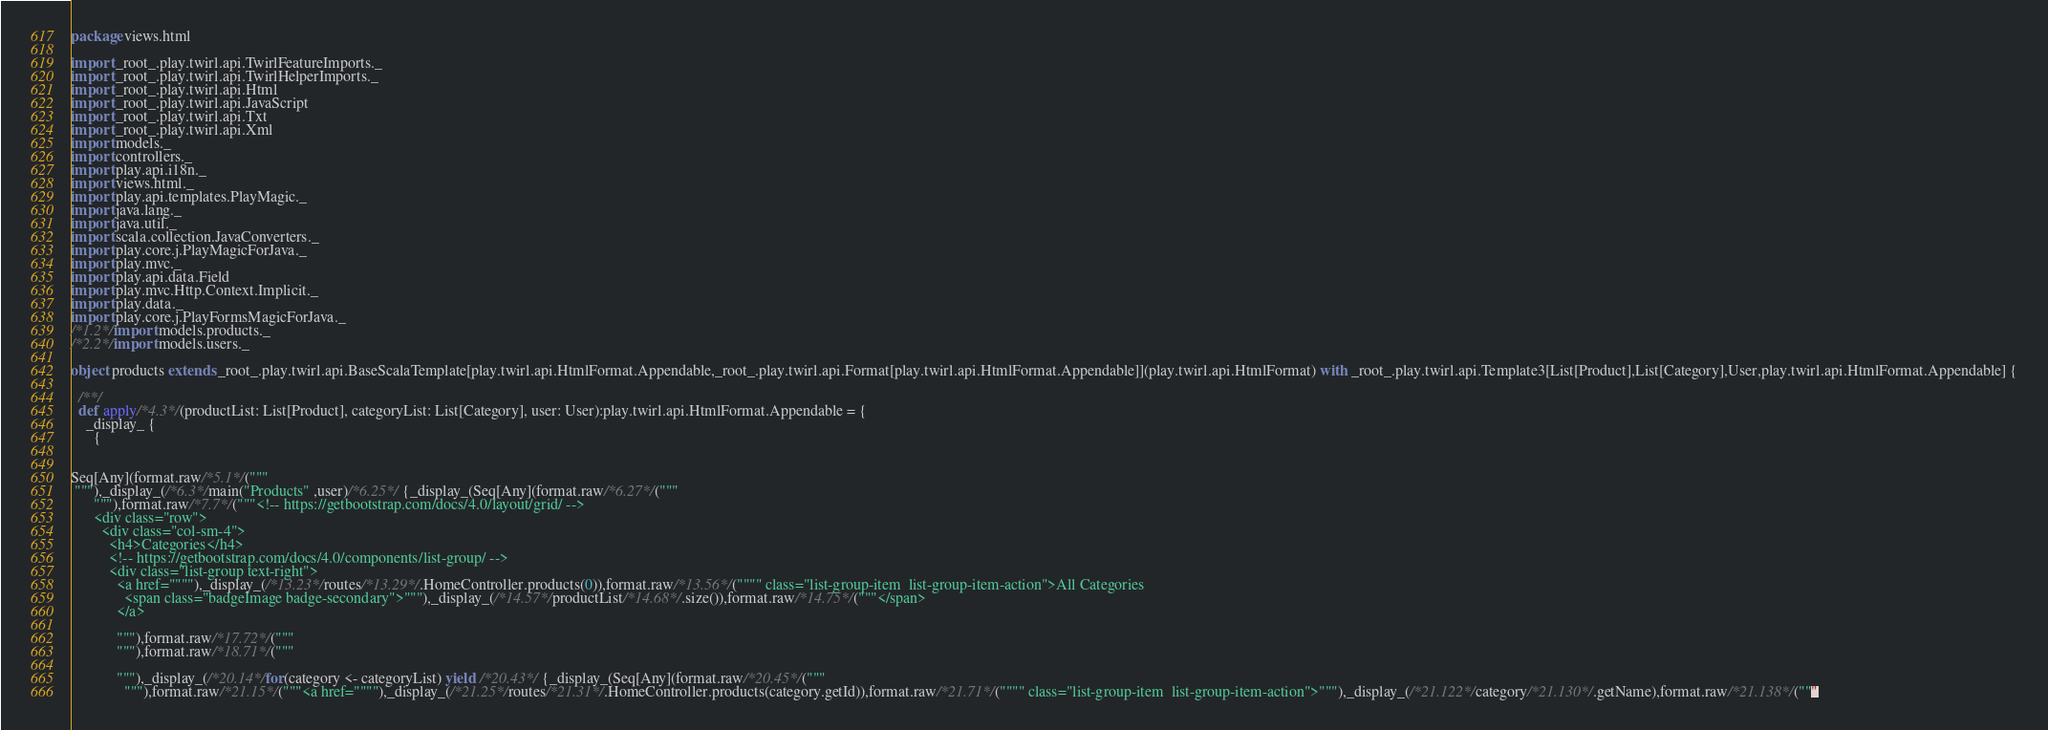<code> <loc_0><loc_0><loc_500><loc_500><_Scala_>
package views.html

import _root_.play.twirl.api.TwirlFeatureImports._
import _root_.play.twirl.api.TwirlHelperImports._
import _root_.play.twirl.api.Html
import _root_.play.twirl.api.JavaScript
import _root_.play.twirl.api.Txt
import _root_.play.twirl.api.Xml
import models._
import controllers._
import play.api.i18n._
import views.html._
import play.api.templates.PlayMagic._
import java.lang._
import java.util._
import scala.collection.JavaConverters._
import play.core.j.PlayMagicForJava._
import play.mvc._
import play.api.data.Field
import play.mvc.Http.Context.Implicit._
import play.data._
import play.core.j.PlayFormsMagicForJava._
/*1.2*/import models.products._
/*2.2*/import models.users._

object products extends _root_.play.twirl.api.BaseScalaTemplate[play.twirl.api.HtmlFormat.Appendable,_root_.play.twirl.api.Format[play.twirl.api.HtmlFormat.Appendable]](play.twirl.api.HtmlFormat) with _root_.play.twirl.api.Template3[List[Product],List[Category],User,play.twirl.api.HtmlFormat.Appendable] {

  /**/
  def apply/*4.3*/(productList: List[Product], categoryList: List[Category], user: User):play.twirl.api.HtmlFormat.Appendable = {
    _display_ {
      {


Seq[Any](format.raw/*5.1*/("""
 """),_display_(/*6.3*/main("Products" ,user)/*6.25*/ {_display_(Seq[Any](format.raw/*6.27*/("""
      """),format.raw/*7.7*/("""<!-- https://getbootstrap.com/docs/4.0/layout/grid/ -->
      <div class="row">
        <div class="col-sm-4">
          <h4>Categories</h4>
          <!-- https://getbootstrap.com/docs/4.0/components/list-group/ -->
          <div class="list-group text-right">
            <a href=""""),_display_(/*13.23*/routes/*13.29*/.HomeController.products(0)),format.raw/*13.56*/("""" class="list-group-item  list-group-item-action">All Categories
              <span class="badgeImage badge-secondary">"""),_display_(/*14.57*/productList/*14.68*/.size()),format.raw/*14.75*/("""</span>
            </a>

            """),format.raw/*17.72*/("""
            """),format.raw/*18.71*/("""
            
            """),_display_(/*20.14*/for(category <- categoryList) yield /*20.43*/ {_display_(Seq[Any](format.raw/*20.45*/("""
              """),format.raw/*21.15*/("""<a href=""""),_display_(/*21.25*/routes/*21.31*/.HomeController.products(category.getId)),format.raw/*21.71*/("""" class="list-group-item  list-group-item-action">"""),_display_(/*21.122*/category/*21.130*/.getName),format.raw/*21.138*/("""</code> 